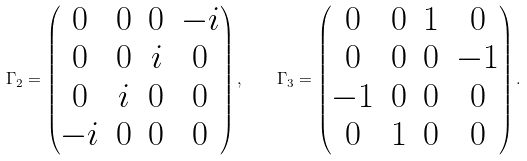<formula> <loc_0><loc_0><loc_500><loc_500>\Gamma _ { 2 } = \begin{pmatrix} 0 & 0 & 0 & - i \\ 0 & 0 & i & 0 \\ 0 & i & 0 & 0 \\ - i & 0 & 0 & 0 \end{pmatrix} , \quad \Gamma _ { 3 } = \begin{pmatrix} 0 & 0 & 1 & 0 \\ 0 & 0 & 0 & - 1 \\ - 1 & 0 & 0 & 0 \\ 0 & 1 & 0 & 0 \end{pmatrix} .</formula> 